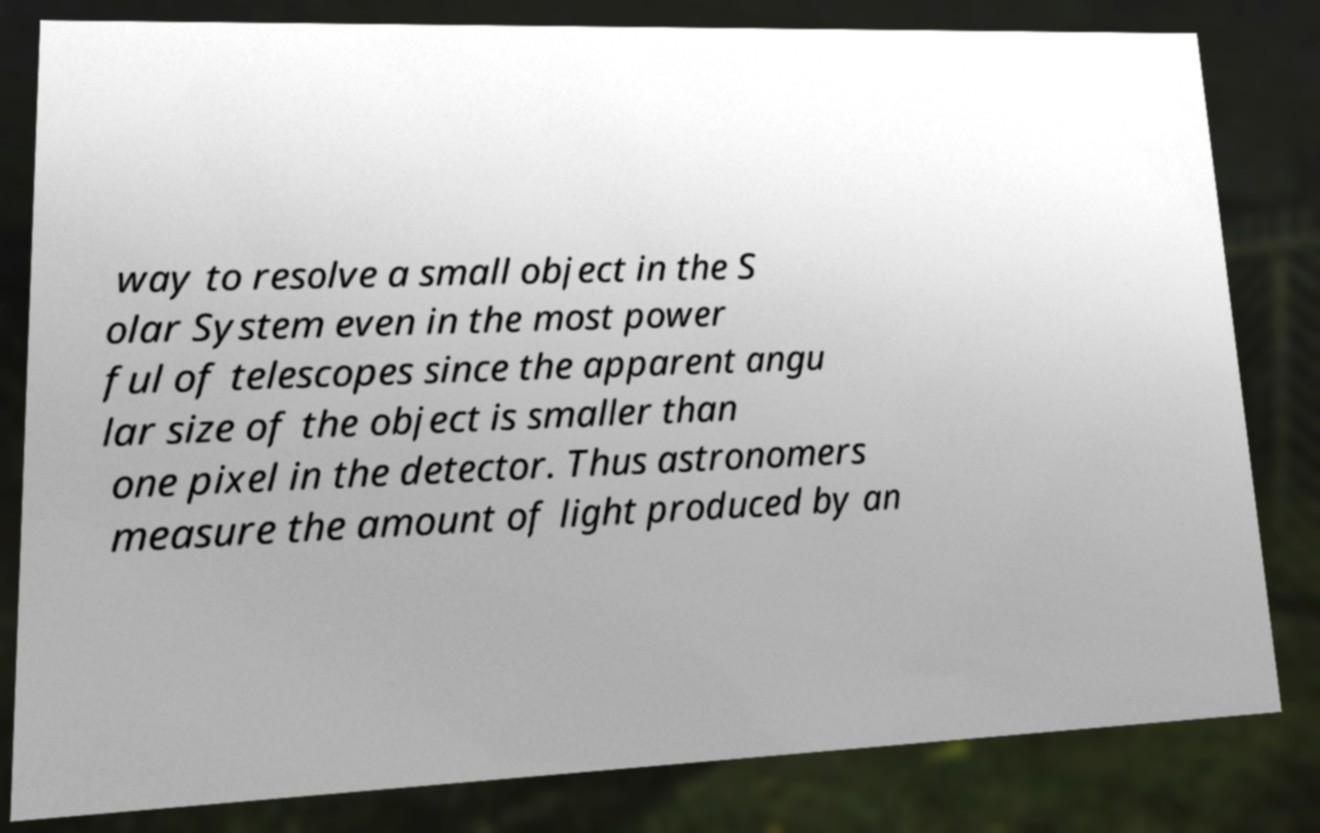Could you extract and type out the text from this image? way to resolve a small object in the S olar System even in the most power ful of telescopes since the apparent angu lar size of the object is smaller than one pixel in the detector. Thus astronomers measure the amount of light produced by an 